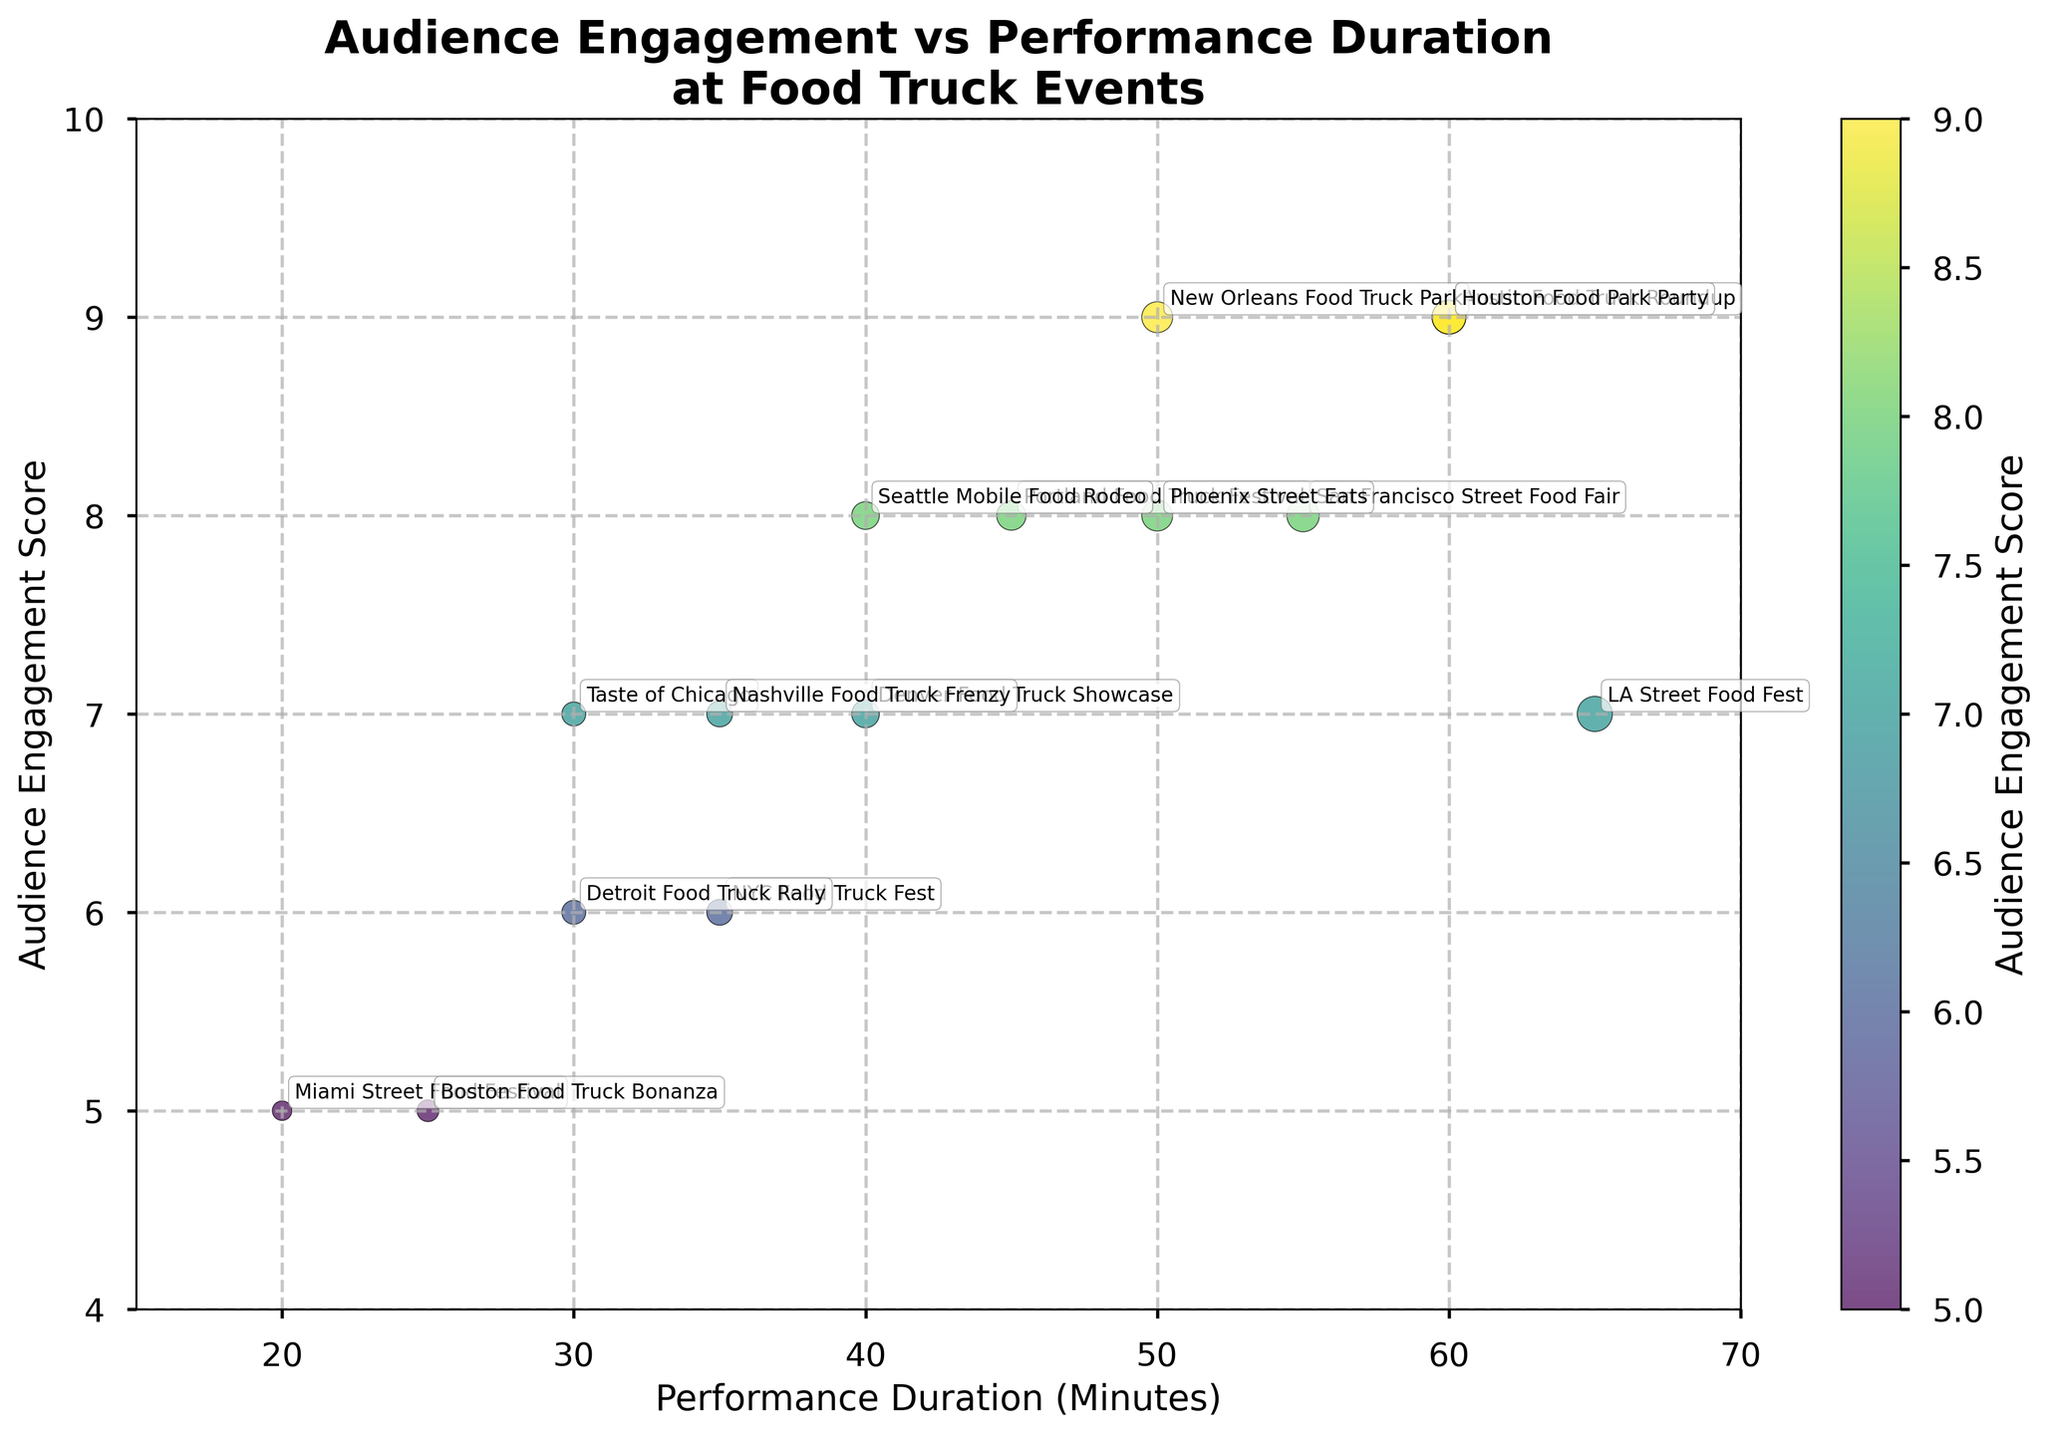How many events have an Audience Engagement Score of 9? Look at the colors and sizes of the circles and check which events have an Audience Engagement Score that aligns with the color used for '9' on the color bar. There are three such points with an Audience Engagement Score of 9.
Answer: 3 What is the title of the scatterplot? Read the title displayed at the top of the scatterplot. It says "Audience Engagement vs Performance Duration at Food Truck Events".
Answer: Audience Engagement vs Performance Duration at Food Truck Events Which event had the highest Performance Duration? Locate the point farthest to the right on the scatterplot and check the event name annotated next to that point. LA Street Food Fest has the highest Performance Duration of 65 minutes.
Answer: LA Street Food Fest How many events have a Performance Duration of less than 35 minutes? Identify the points on the scatterplot where the x-axis values are less than 35 and count these points. There are four such points (20, 25, 30, 30).
Answer: 4 Is there an event with a Performance Duration of 50 minutes and an Audience Engagement Score of 8? If yes, name the event. Locate the point positioned at (50, 8) on the scatterplot and check the event name annotated next to that point. The event is Phoenix Street Eats.
Answer: Phoenix Street Eats Which event had the lowest Audience Engagement Score? Locate the point lowest on the y-axis and check the event name annotated next to that point. Miami Street Food Festival and Boston Food Truck Bonanza both had an Audience Engagement Score of 5.
Answer: Miami Street Food Festival, Boston Food Truck Bonanza What is the average Audience Engagement Score for events with a Performance Duration greater than 40 minutes? Locate the points where the Performance Duration is greater than 40 minutes, then calculate the average of the Audience Engagement Scores for these points (8, 9, 8, 8, 7, 9). Sum: 49, Number of events: 6, so 49/6 = 8.17.
Answer: 8.17 Which events have the same Audience Engagement Score of 7? Look at where the colors and sizes of the points align with the score 7 from the color bar and identify the events annotated next to these points. The events are LA Street Food Fest, Nashville Food Truck Frenzy, Taste of Chicago, and Denver Food Truck Showcase.
Answer: LA Street Food Fest, Nashville Food Truck Frenzy, Taste of Chicago, Denver Food Truck Showcase What is the relationship between Performance Duration and Audience Engagement Score for an event with a Performance Duration of 60 minutes? Locate the point(s) where the Performance Duration is 60 minutes and then read the corresponding Audience Engagement Scores and event names. Austin Food Truck Roundup and Houston Food Park Party have a score of 9.
Answer: Performance Duration increases the Audience Engagement Score to 9 for these events How many events have a Performance Duration of exactly 50 minutes? Locate the points where the Performance Duration is exactly 50 minutes and count the number of such points. There are two points at (50, 9) for New Orleans Food Truck Park and (50, 8) for Phoenix Street Eats.
Answer: 2 